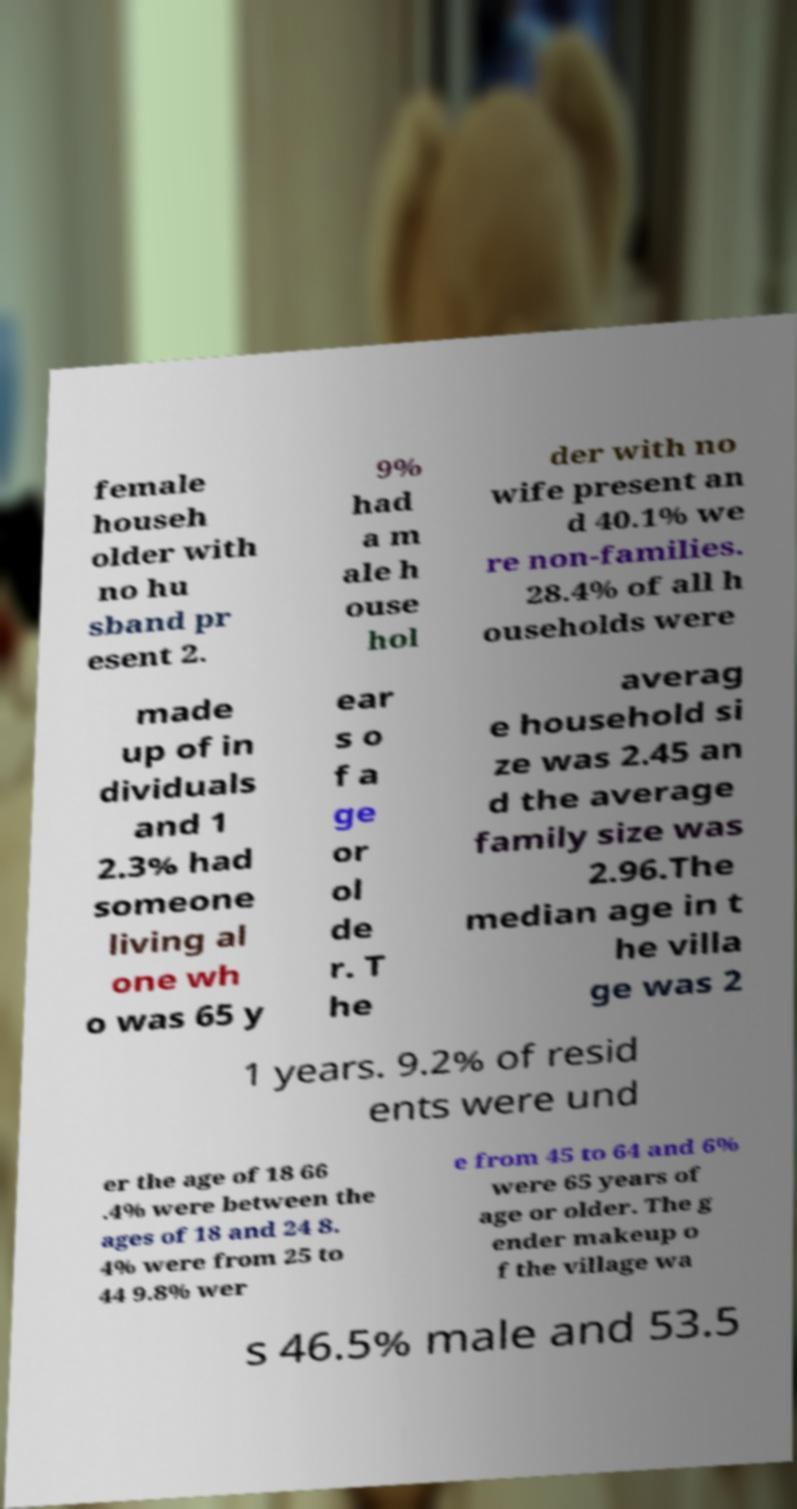Please identify and transcribe the text found in this image. female househ older with no hu sband pr esent 2. 9% had a m ale h ouse hol der with no wife present an d 40.1% we re non-families. 28.4% of all h ouseholds were made up of in dividuals and 1 2.3% had someone living al one wh o was 65 y ear s o f a ge or ol de r. T he averag e household si ze was 2.45 an d the average family size was 2.96.The median age in t he villa ge was 2 1 years. 9.2% of resid ents were und er the age of 18 66 .4% were between the ages of 18 and 24 8. 4% were from 25 to 44 9.8% wer e from 45 to 64 and 6% were 65 years of age or older. The g ender makeup o f the village wa s 46.5% male and 53.5 